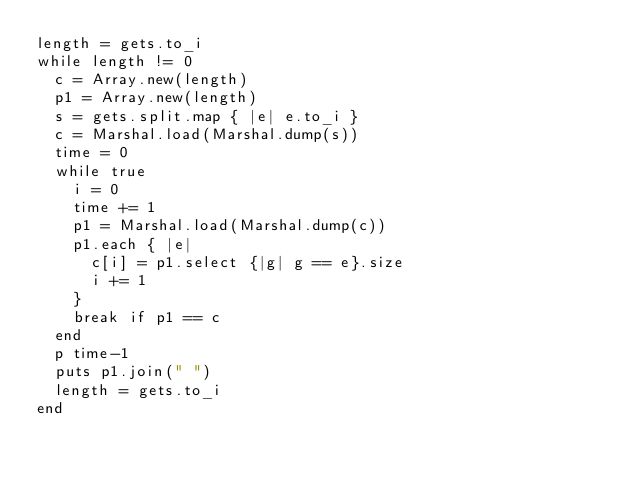<code> <loc_0><loc_0><loc_500><loc_500><_Ruby_>length = gets.to_i
while length != 0
  c = Array.new(length)
  p1 = Array.new(length)
  s = gets.split.map { |e| e.to_i }
  c = Marshal.load(Marshal.dump(s))
  time = 0
  while true
    i = 0
    time += 1
    p1 = Marshal.load(Marshal.dump(c))
    p1.each { |e|
      c[i] = p1.select {|g| g == e}.size
      i += 1
    }
    break if p1 == c
  end
  p time-1
  puts p1.join(" ")
  length = gets.to_i
end</code> 